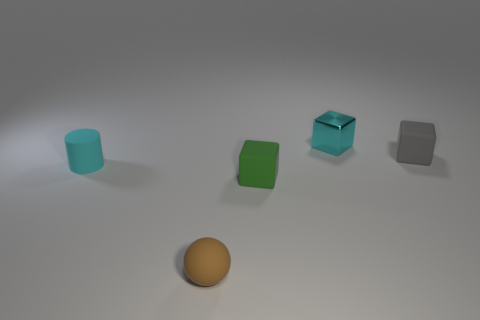What size is the cyan matte thing?
Offer a very short reply. Small. What number of other things are the same color as the metallic cube?
Keep it short and to the point. 1. There is a object behind the gray matte block; is its shape the same as the small cyan rubber object?
Your response must be concise. No. What is the color of the shiny thing that is the same shape as the green rubber object?
Your answer should be very brief. Cyan. Is there any other thing that is made of the same material as the ball?
Offer a very short reply. Yes. There is a cyan shiny object that is the same shape as the gray object; what is its size?
Your response must be concise. Small. The small thing that is in front of the tiny cylinder and right of the rubber ball is made of what material?
Your response must be concise. Rubber. There is a rubber cube to the left of the gray thing; is its color the same as the tiny cylinder?
Make the answer very short. No. There is a tiny rubber cylinder; is it the same color as the small metallic block that is behind the tiny brown object?
Keep it short and to the point. Yes. Are there any tiny green matte objects in front of the rubber sphere?
Your answer should be compact. No. 